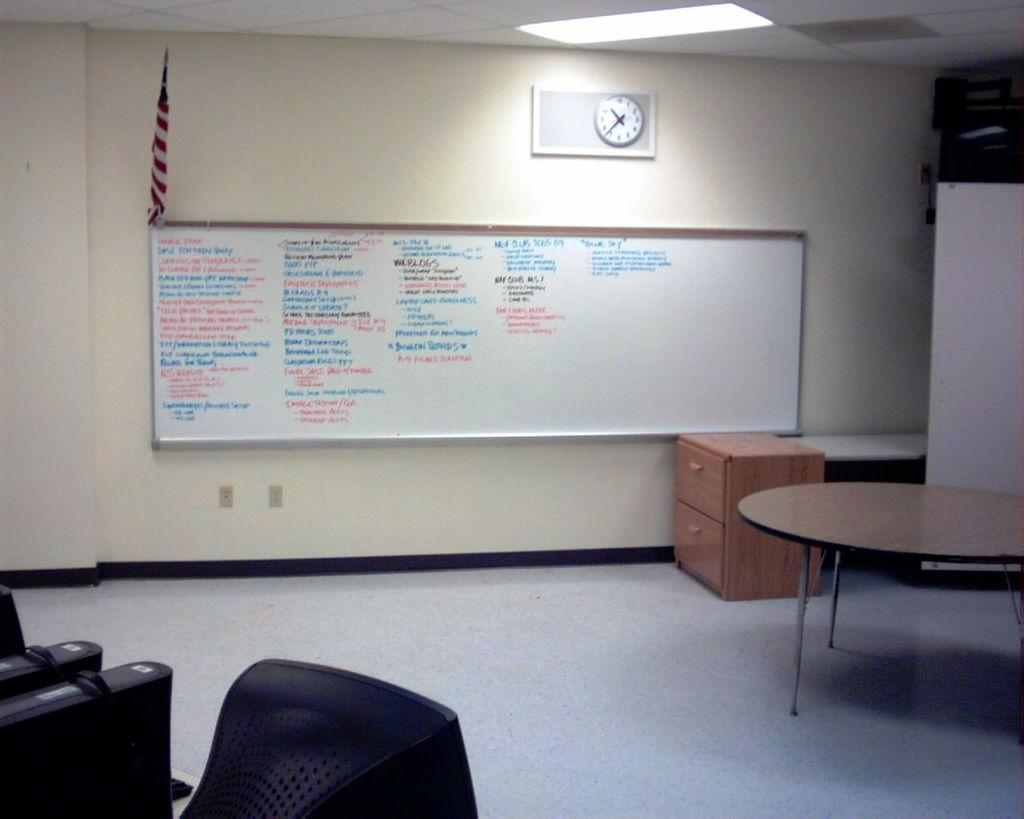What type of furniture is present in the room? There is a table and a cupboard in the room. What other objects can be found in the room? There is a board, a flag, a watch, a monitor, a CPU, and a light in the room. What is the purpose of the board in the room? The purpose of the board is not specified in the facts, but it is present in the room. What type of wall is in the room? The facts do not specify the type of wall, only that there is a wall in the room. What type of honey can be seen dripping from the flag in the room? There is no honey present in the image, and the flag is not described as having any honey on it. 